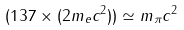Convert formula to latex. <formula><loc_0><loc_0><loc_500><loc_500>( 1 3 7 \times ( 2 m _ { e } c ^ { 2 } ) ) \simeq m _ { \pi } c ^ { 2 }</formula> 